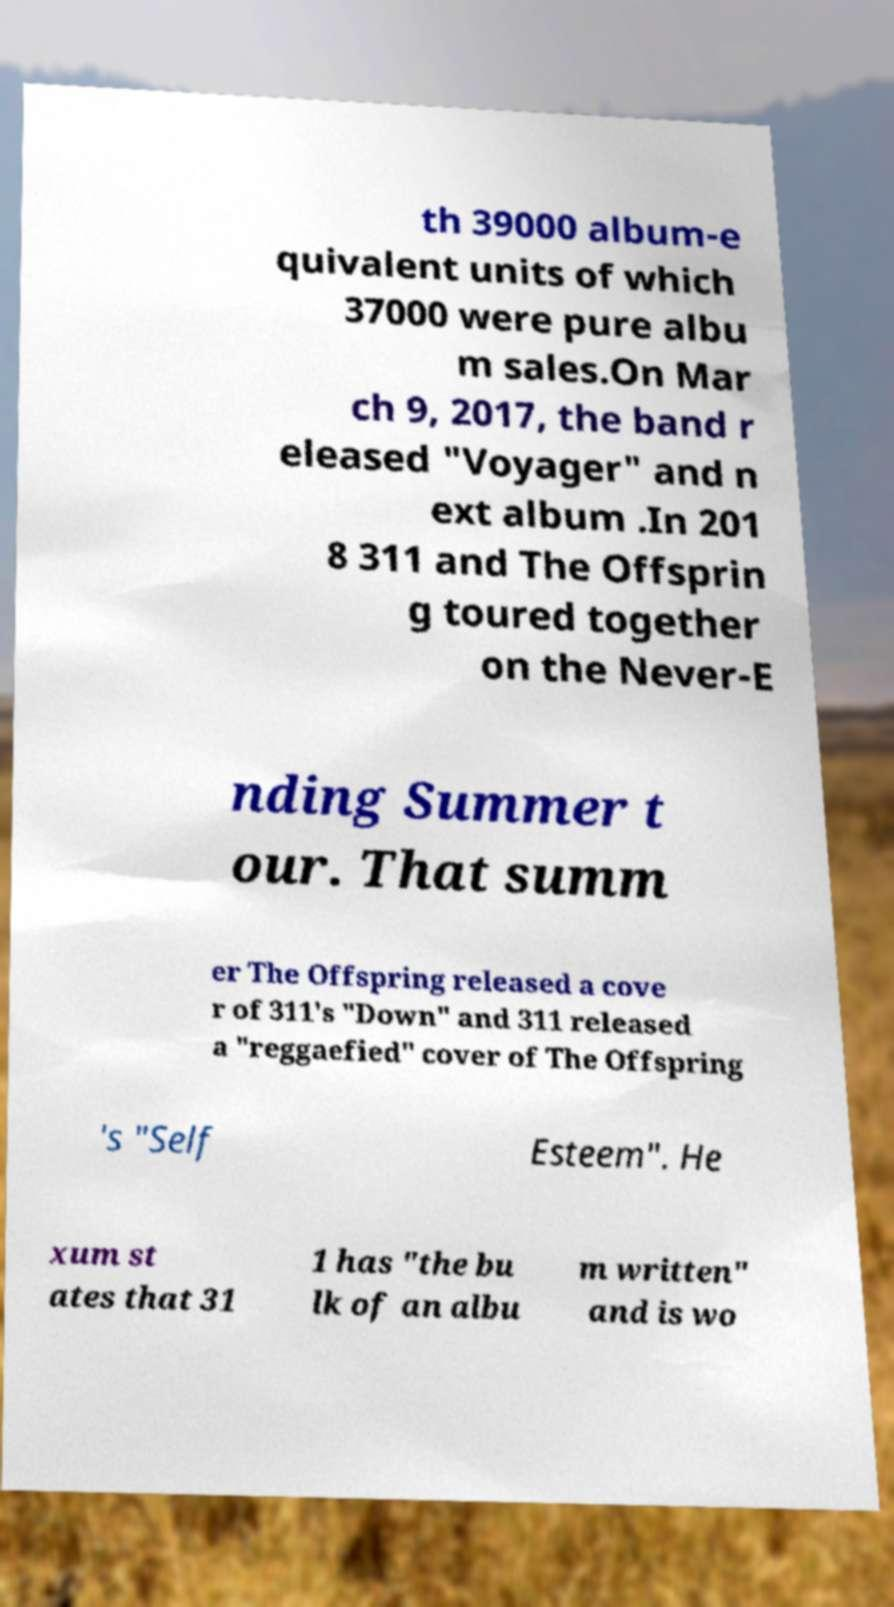What messages or text are displayed in this image? I need them in a readable, typed format. th 39000 album-e quivalent units of which 37000 were pure albu m sales.On Mar ch 9, 2017, the band r eleased "Voyager" and n ext album .In 201 8 311 and The Offsprin g toured together on the Never-E nding Summer t our. That summ er The Offspring released a cove r of 311's "Down" and 311 released a "reggaefied" cover of The Offspring 's "Self Esteem". He xum st ates that 31 1 has "the bu lk of an albu m written" and is wo 